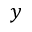<formula> <loc_0><loc_0><loc_500><loc_500>y</formula> 